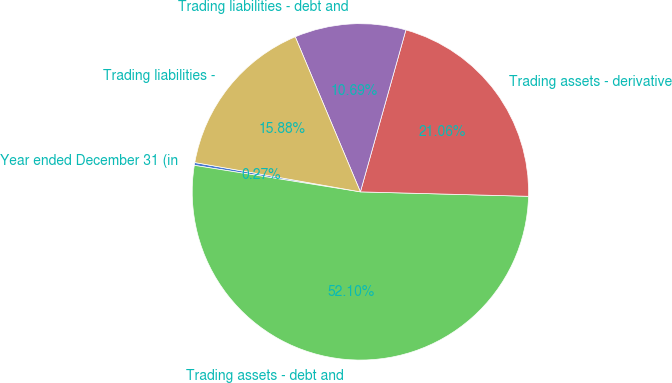<chart> <loc_0><loc_0><loc_500><loc_500><pie_chart><fcel>Year ended December 31 (in<fcel>Trading assets - debt and<fcel>Trading assets - derivative<fcel>Trading liabilities - debt and<fcel>Trading liabilities -<nl><fcel>0.27%<fcel>52.1%<fcel>21.06%<fcel>10.69%<fcel>15.88%<nl></chart> 